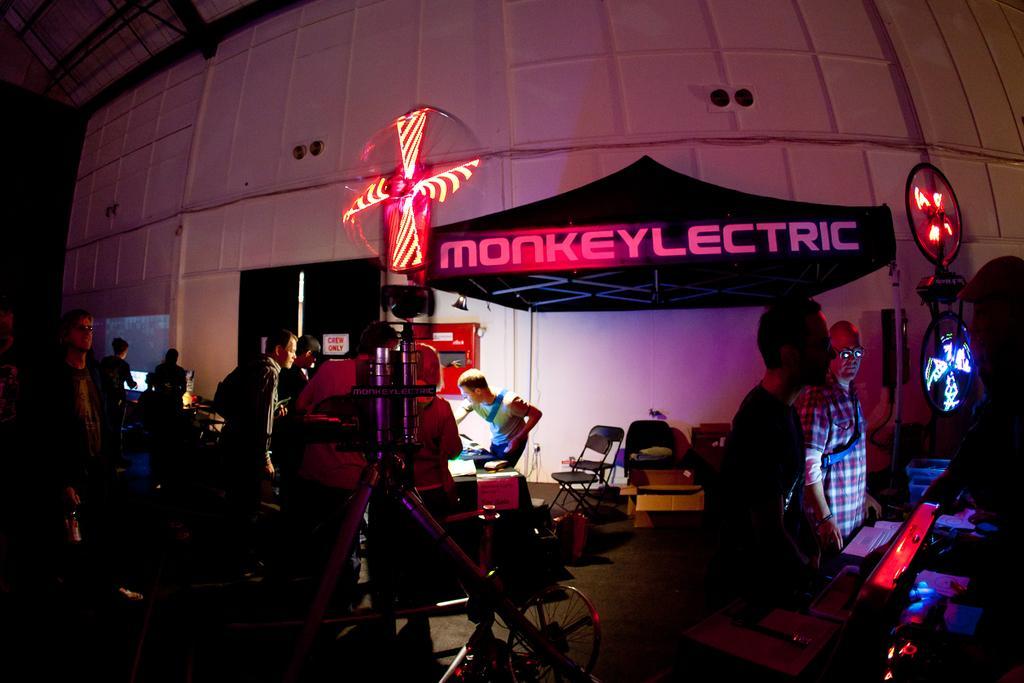In one or two sentences, can you explain what this image depicts? In the image in the center, we can see a few people are standing. And we can see one cycle, chairs, boxes, lights, one monitor and a few other objects. In the background there is a wall, roof, door, banner, lights etc. 